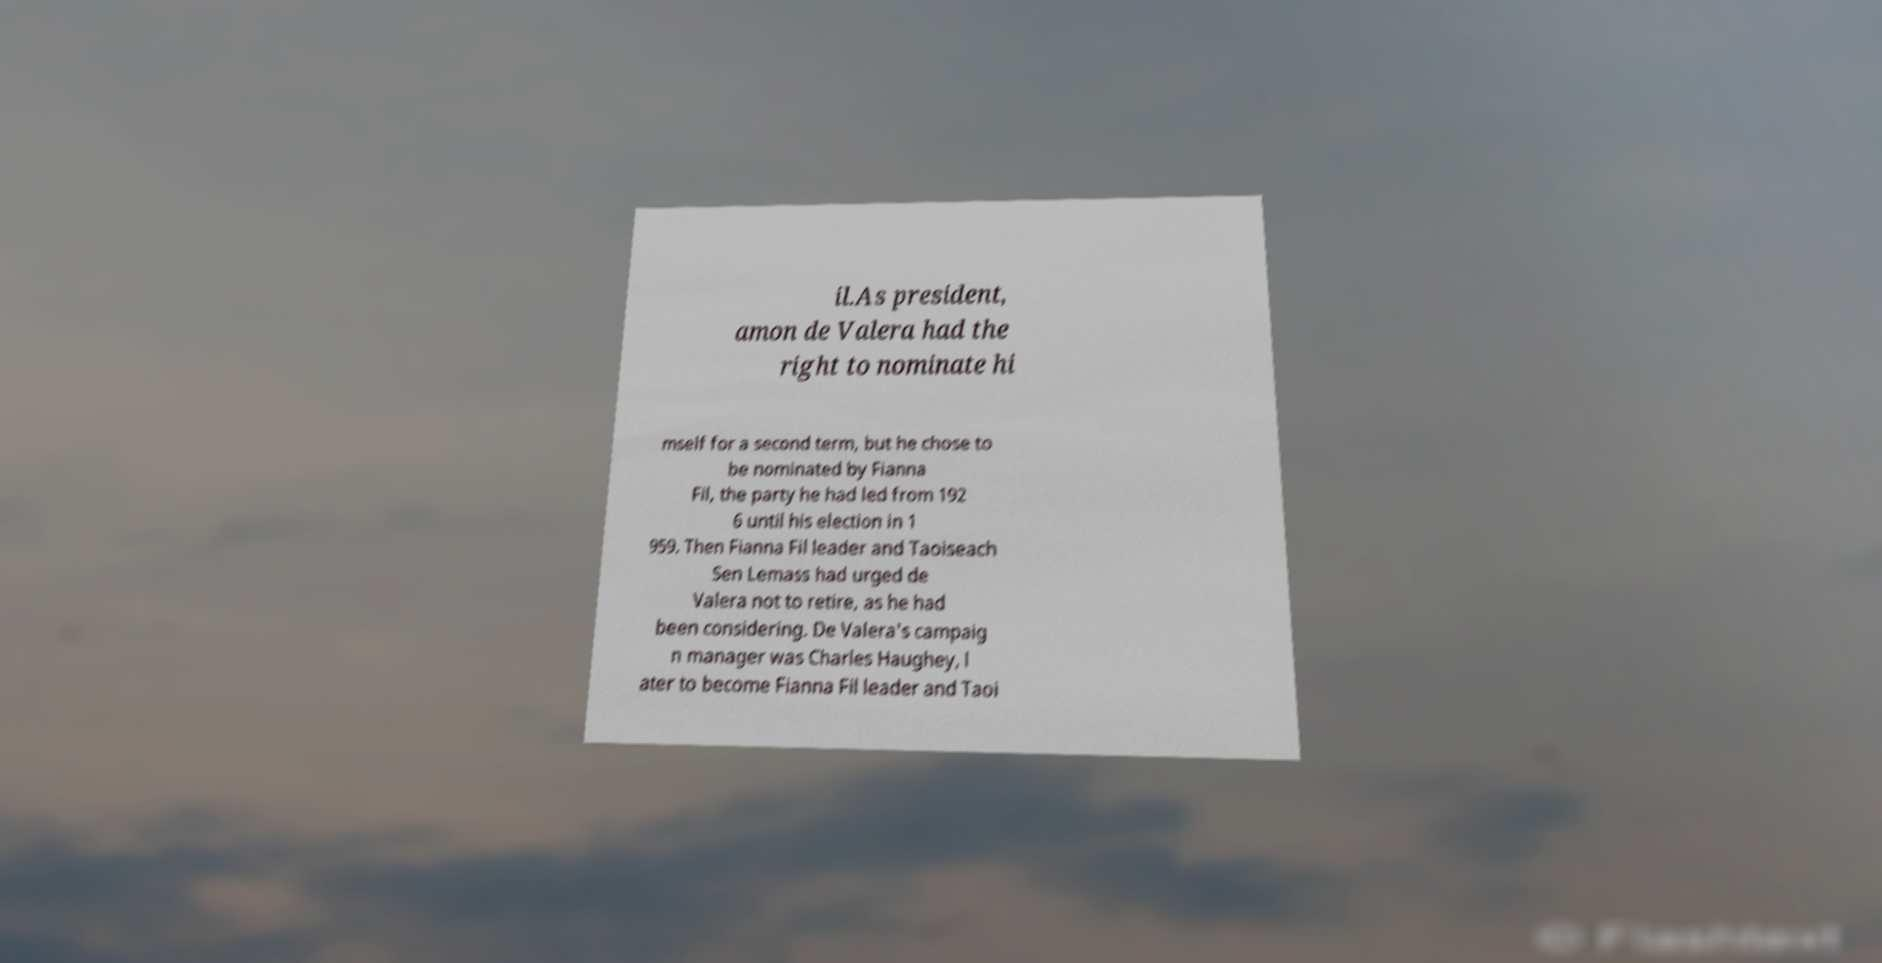Could you extract and type out the text from this image? il.As president, amon de Valera had the right to nominate hi mself for a second term, but he chose to be nominated by Fianna Fil, the party he had led from 192 6 until his election in 1 959. Then Fianna Fil leader and Taoiseach Sen Lemass had urged de Valera not to retire, as he had been considering. De Valera's campaig n manager was Charles Haughey, l ater to become Fianna Fil leader and Taoi 